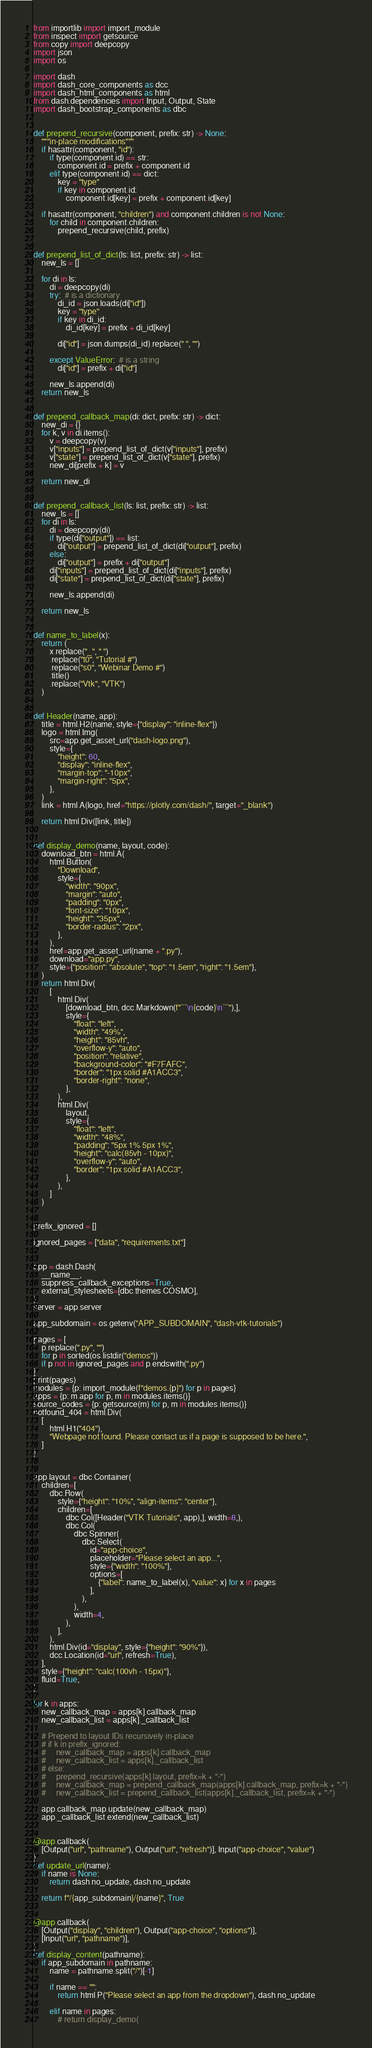Convert code to text. <code><loc_0><loc_0><loc_500><loc_500><_Python_>from importlib import import_module
from inspect import getsource
from copy import deepcopy
import json
import os

import dash
import dash_core_components as dcc
import dash_html_components as html
from dash.dependencies import Input, Output, State
import dash_bootstrap_components as dbc


def prepend_recursive(component, prefix: str) -> None:
    """in-place modifications"""
    if hasattr(component, "id"):
        if type(component.id) == str:
            component.id = prefix + component.id
        elif type(component.id) == dict:
            key = "type"
            if key in component.id:
                component.id[key] = prefix + component.id[key]

    if hasattr(component, "children") and component.children is not None:
        for child in component.children:
            prepend_recursive(child, prefix)


def prepend_list_of_dict(ls: list, prefix: str) -> list:
    new_ls = []

    for di in ls:
        di = deepcopy(di)
        try:  # is a dictionary
            di_id = json.loads(di["id"])
            key = "type"
            if key in di_id:
                di_id[key] = prefix + di_id[key]

            di["id"] = json.dumps(di_id).replace(" ", "")

        except ValueError:  # is a string
            di["id"] = prefix + di["id"]

        new_ls.append(di)
    return new_ls


def prepend_callback_map(di: dict, prefix: str) -> dict:
    new_di = {}
    for k, v in di.items():
        v = deepcopy(v)
        v["inputs"] = prepend_list_of_dict(v["inputs"], prefix)
        v["state"] = prepend_list_of_dict(v["state"], prefix)
        new_di[prefix + k] = v

    return new_di


def prepend_callback_list(ls: list, prefix: str) -> list:
    new_ls = []
    for di in ls:
        di = deepcopy(di)
        if type(di["output"]) == list:
            di["output"] = prepend_list_of_dict(di["output"], prefix)
        else:
            di["output"] = prefix + di["output"]
        di["inputs"] = prepend_list_of_dict(di["inputs"], prefix)
        di["state"] = prepend_list_of_dict(di["state"], prefix)

        new_ls.append(di)

    return new_ls


def name_to_label(x):
    return (
        x.replace("_", " ")
        .replace("t0", "Tutorial #")
        .replace("s0", "Webinar Demo #")
        .title()
        .replace("Vtk", "VTK")
    )


def Header(name, app):
    title = html.H2(name, style={"display": "inline-flex"})
    logo = html.Img(
        src=app.get_asset_url("dash-logo.png"),
        style={
            "height": 60,
            "display": "inline-flex",
            "margin-top": "-10px",
            "margin-right": "5px",
        },
    )
    link = html.A(logo, href="https://plotly.com/dash/", target="_blank")

    return html.Div([link, title])


def display_demo(name, layout, code):
    download_btn = html.A(
        html.Button(
            "Download",
            style={
                "width": "90px",
                "margin": "auto",
                "padding": "0px",
                "font-size": "10px",
                "height": "35px",
                "border-radius": "2px",
            },
        ),
        href=app.get_asset_url(name + ".py"),
        download="app.py",
        style={"position": "absolute", "top": "1.5em", "right": "1.5em"},
    )
    return html.Div(
        [
            html.Div(
                [download_btn, dcc.Markdown(f"```\n{code}\n```"),],
                style={
                    "float": "left",
                    "width": "49%",
                    "height": "85vh",
                    "overflow-y": "auto",
                    "position": "relative",
                    "background-color": "#F7FAFC",
                    "border": "1px solid #A1ACC3",
                    "border-right": "none",
                },
            ),
            html.Div(
                layout,
                style={
                    "float": "left",
                    "width": "48%",
                    "padding": "5px 1% 5px 1%",
                    "height": "calc(85vh - 10px)",
                    "overflow-y": "auto",
                    "border": "1px solid #A1ACC3",
                },
            ),
        ]
    )


prefix_ignored = []

ignored_pages = ["data", "requirements.txt"]


app = dash.Dash(
    __name__,
    suppress_callback_exceptions=True,
    external_stylesheets=[dbc.themes.COSMO],
)
server = app.server

app_subdomain = os.getenv("APP_SUBDOMAIN", "dash-vtk-tutorials")

pages = [
    p.replace(".py", "")
    for p in sorted(os.listdir("demos"))
    if p not in ignored_pages and p.endswith(".py")
]
print(pages)
modules = {p: import_module(f"demos.{p}") for p in pages}
apps = {p: m.app for p, m in modules.items()}
source_codes = {p: getsource(m) for p, m in modules.items()}
notfound_404 = html.Div(
    [
        html.H1("404"),
        "Webpage not found. Please contact us if a page is supposed to be here.",
    ]
)


app.layout = dbc.Container(
    children=[
        dbc.Row(
            style={"height": "10%", "align-items": "center"},
            children=[
                dbc.Col([Header("VTK Tutorials", app),], width=8,),
                dbc.Col(
                    dbc.Spinner(
                        dbc.Select(
                            id="app-choice",
                            placeholder="Please select an app...",
                            style={"width": "100%"},
                            options=[
                                {"label": name_to_label(x), "value": x} for x in pages
                            ],
                        ),
                    ),
                    width=4,
                ),
            ],
        ),
        html.Div(id="display", style={"height": "90%"}),
        dcc.Location(id="url", refresh=True),
    ],
    style={"height": "calc(100vh - 15px)"},
    fluid=True,
)

for k in apps:
    new_callback_map = apps[k].callback_map
    new_callback_list = apps[k]._callback_list

    # Prepend to layout IDs recursively in-place
    # if k in prefix_ignored:
    #     new_callback_map = apps[k].callback_map
    #     new_callback_list = apps[k]._callback_list
    # else:
    #     prepend_recursive(apps[k].layout, prefix=k + "-")
    #     new_callback_map = prepend_callback_map(apps[k].callback_map, prefix=k + "-")
    #     new_callback_list = prepend_callback_list(apps[k]._callback_list, prefix=k + "-")

    app.callback_map.update(new_callback_map)
    app._callback_list.extend(new_callback_list)


@app.callback(
    [Output("url", "pathname"), Output("url", "refresh")], Input("app-choice", "value")
)
def update_url(name):
    if name is None:
        return dash.no_update, dash.no_update

    return f"/{app_subdomain}/{name}", True


@app.callback(
    [Output("display", "children"), Output("app-choice", "options")],
    [Input("url", "pathname")],
)
def display_content(pathname):
    if app_subdomain in pathname:
        name = pathname.split("/")[-1]

        if name == "":
            return html.P("Please select an app from the dropdown"), dash.no_update

        elif name in pages:
            # return display_demo(</code> 